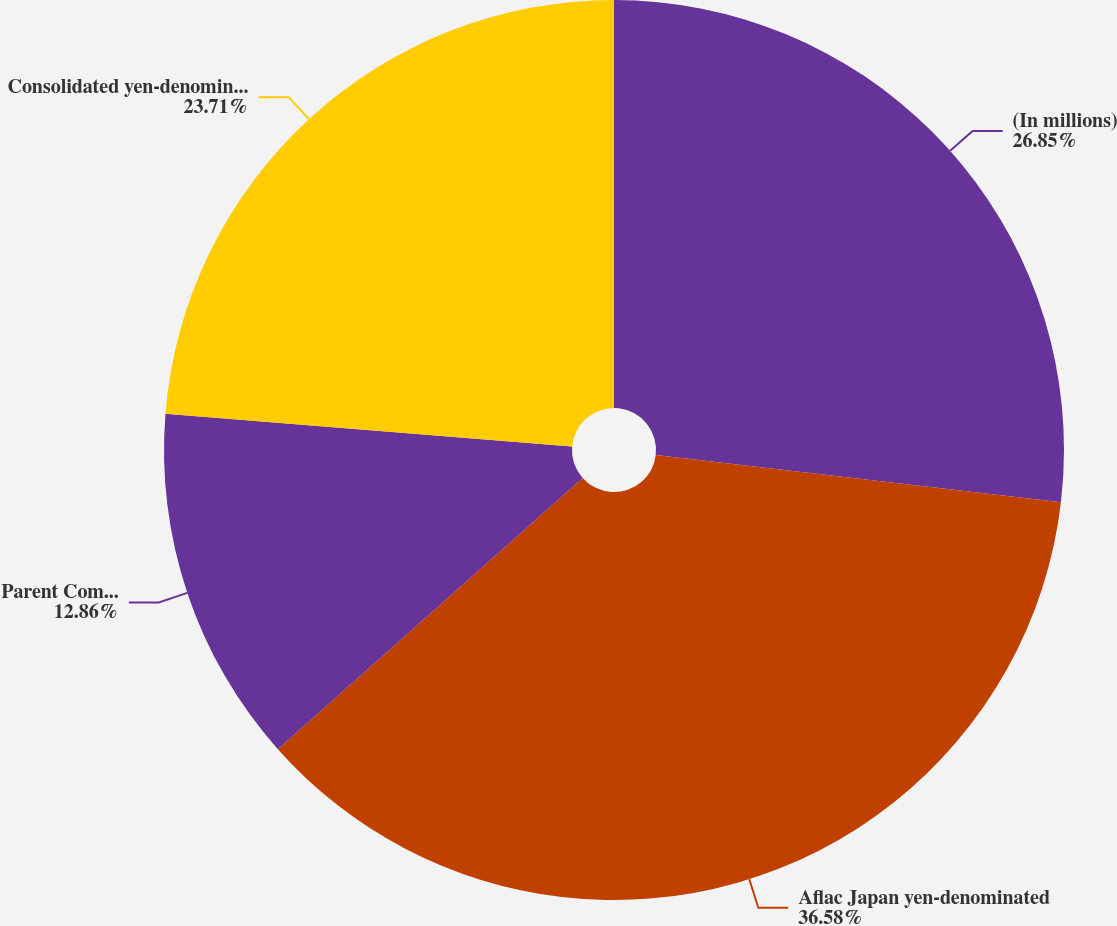Convert chart to OTSL. <chart><loc_0><loc_0><loc_500><loc_500><pie_chart><fcel>(In millions)<fcel>Aflac Japan yen-denominated<fcel>Parent Company yen-denominated<fcel>Consolidated yen-denominated<nl><fcel>26.85%<fcel>36.57%<fcel>12.86%<fcel>23.71%<nl></chart> 